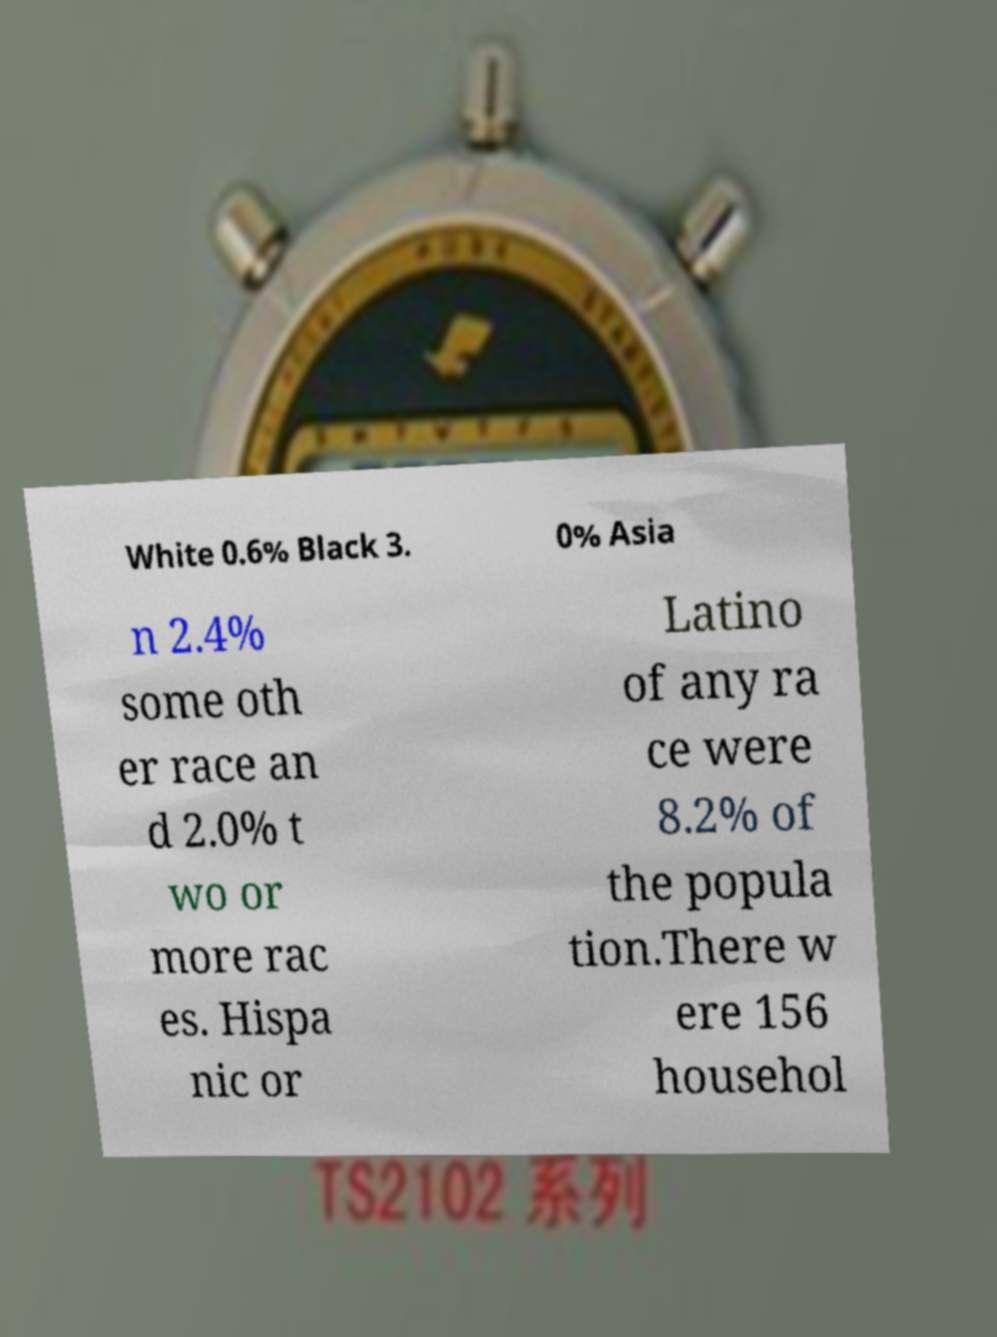Please read and relay the text visible in this image. What does it say? White 0.6% Black 3. 0% Asia n 2.4% some oth er race an d 2.0% t wo or more rac es. Hispa nic or Latino of any ra ce were 8.2% of the popula tion.There w ere 156 househol 